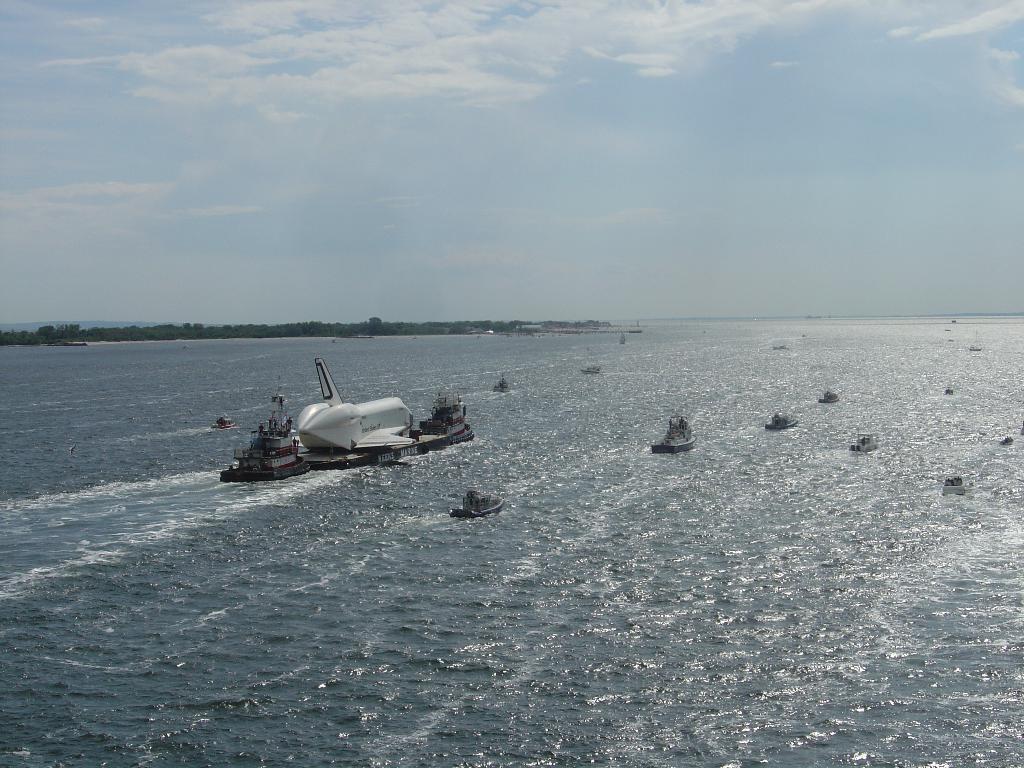In one or two sentences, can you explain what this image depicts? Here we can see ships on the water. Background we can see trees and sky with clouds. 